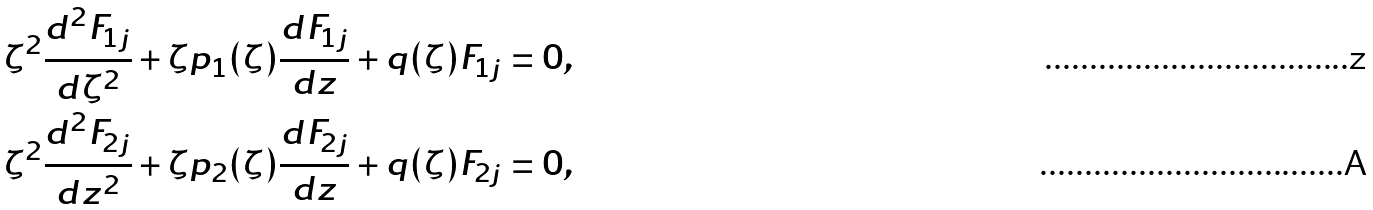Convert formula to latex. <formula><loc_0><loc_0><loc_500><loc_500>\zeta ^ { 2 } \frac { d ^ { 2 } F _ { 1 j } } { d \zeta ^ { 2 } } + \zeta p _ { 1 } ( \zeta ) \frac { d F _ { 1 j } } { d z } + q ( \zeta ) F _ { 1 j } & = 0 , \\ \zeta ^ { 2 } \frac { d ^ { 2 } F _ { 2 j } } { d z ^ { 2 } } + \zeta p _ { 2 } ( \zeta ) \frac { d F _ { 2 j } } { d z } + q ( \zeta ) F _ { 2 j } & = 0 ,</formula> 